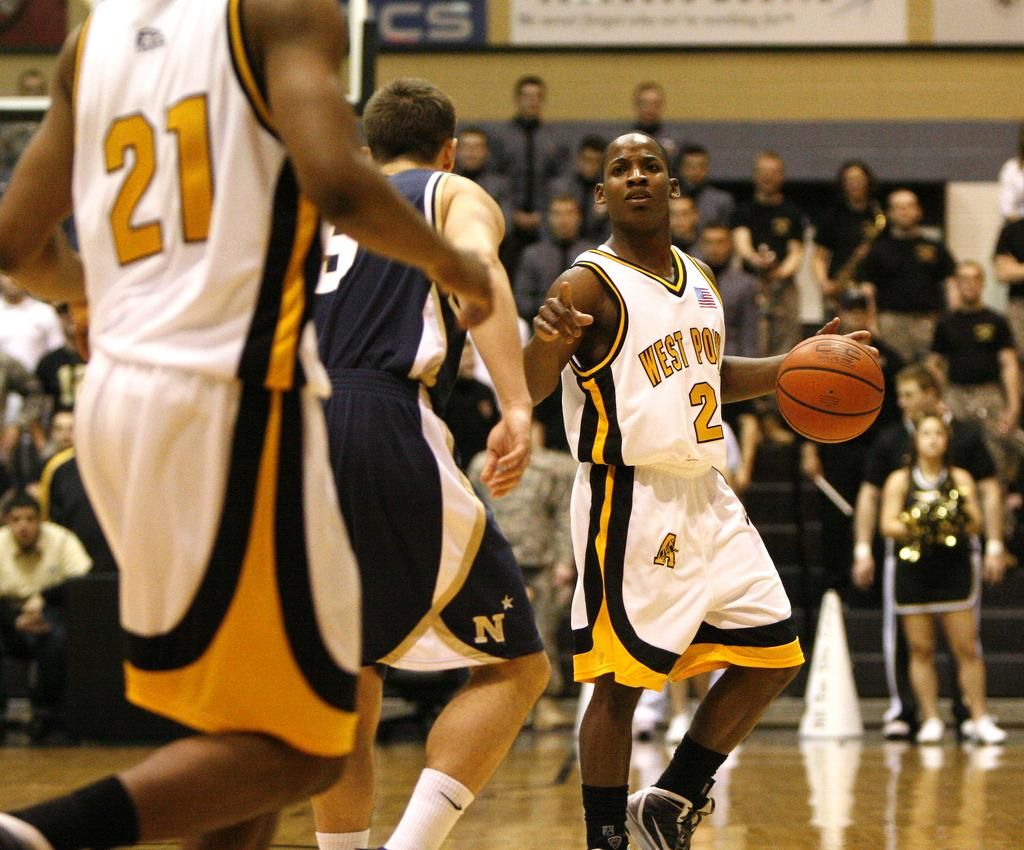<image>
Render a clear and concise summary of the photo. Basketball player number 2 for west Point dribbling a basketball. 